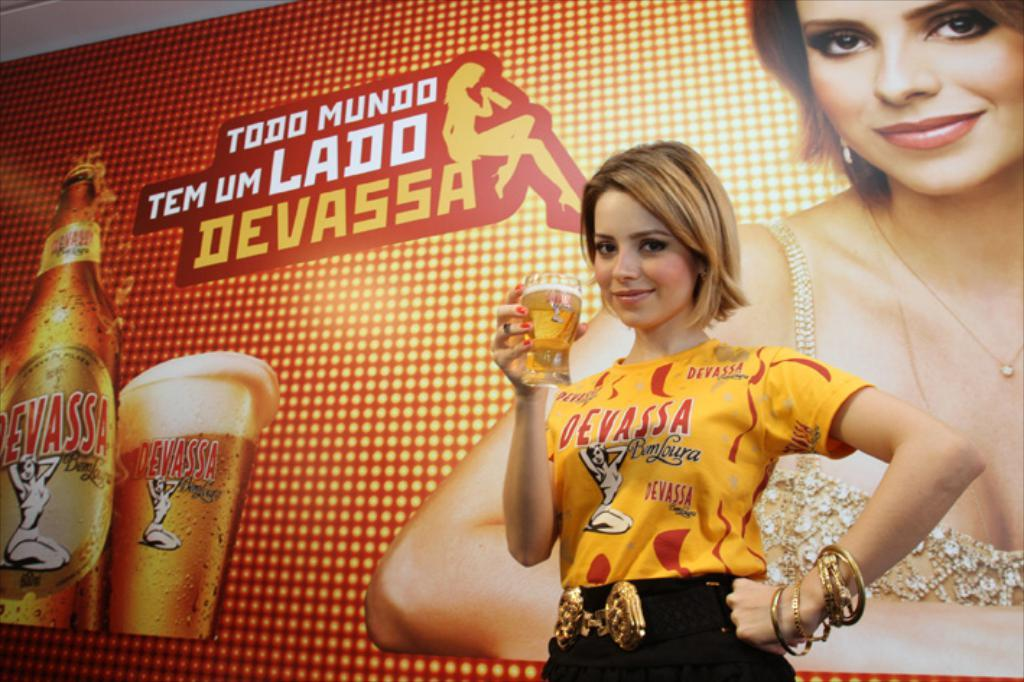<image>
Describe the image concisely. A woman is holding a glass of Devassa beer in front of an advertising poster. 